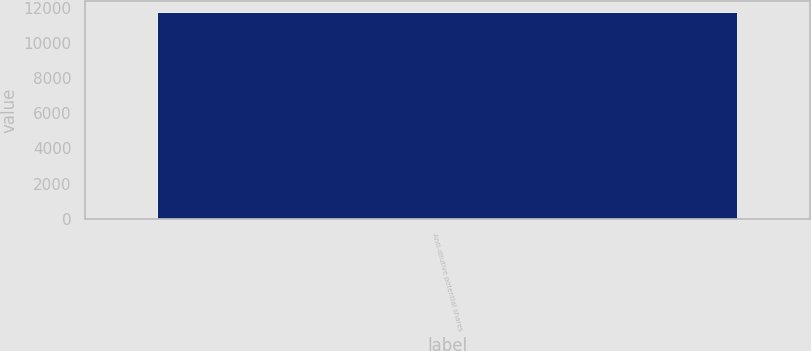Convert chart to OTSL. <chart><loc_0><loc_0><loc_500><loc_500><bar_chart><fcel>Anti-dilutive potential shares<nl><fcel>11771<nl></chart> 